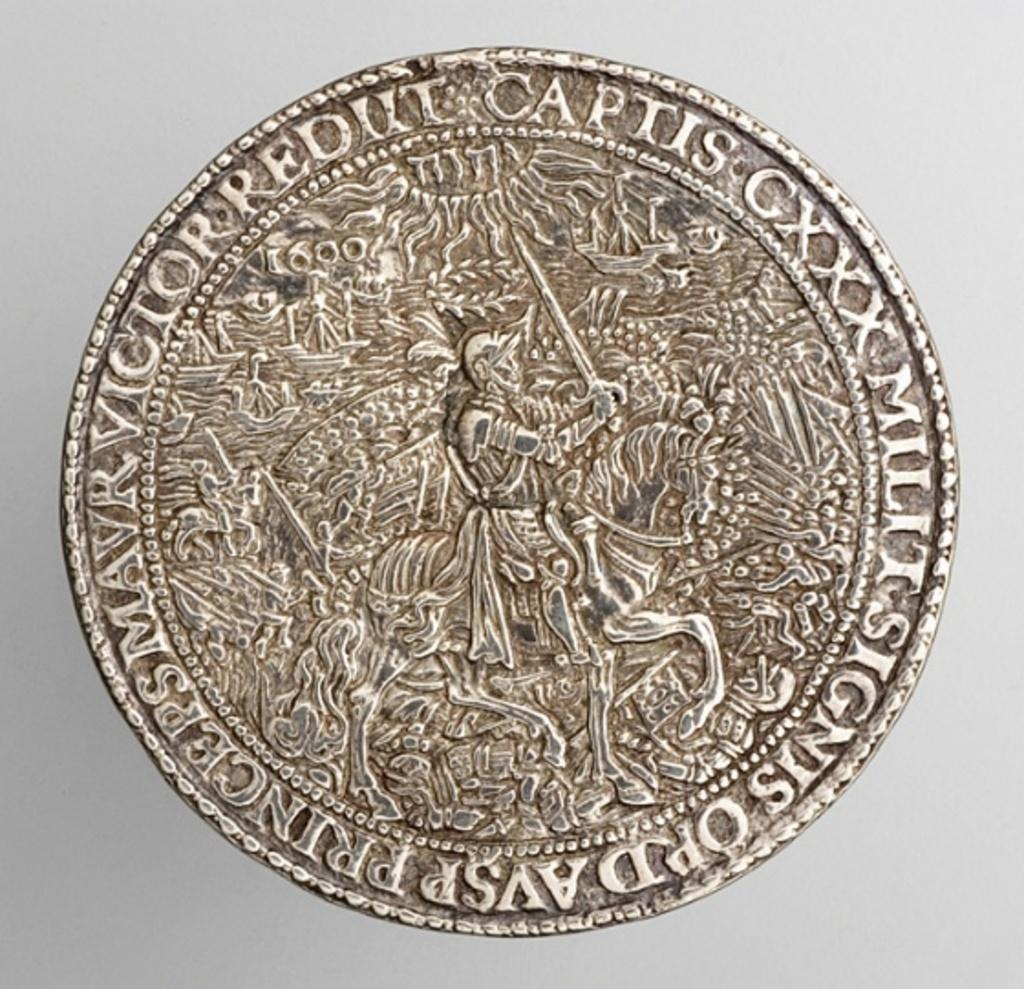Provide a one-sentence caption for the provided image. The old collectors coin has lots of detail of a battle. 